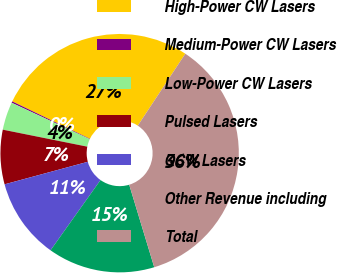<chart> <loc_0><loc_0><loc_500><loc_500><pie_chart><fcel>High-Power CW Lasers<fcel>Medium-Power CW Lasers<fcel>Low-Power CW Lasers<fcel>Pulsed Lasers<fcel>QCW Lasers<fcel>Other Revenue including<fcel>Total<nl><fcel>27.14%<fcel>0.2%<fcel>3.79%<fcel>7.37%<fcel>10.95%<fcel>14.53%<fcel>36.02%<nl></chart> 